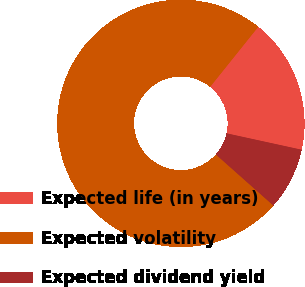Convert chart. <chart><loc_0><loc_0><loc_500><loc_500><pie_chart><fcel>Expected life (in years)<fcel>Expected volatility<fcel>Expected dividend yield<nl><fcel>17.67%<fcel>74.2%<fcel>8.13%<nl></chart> 